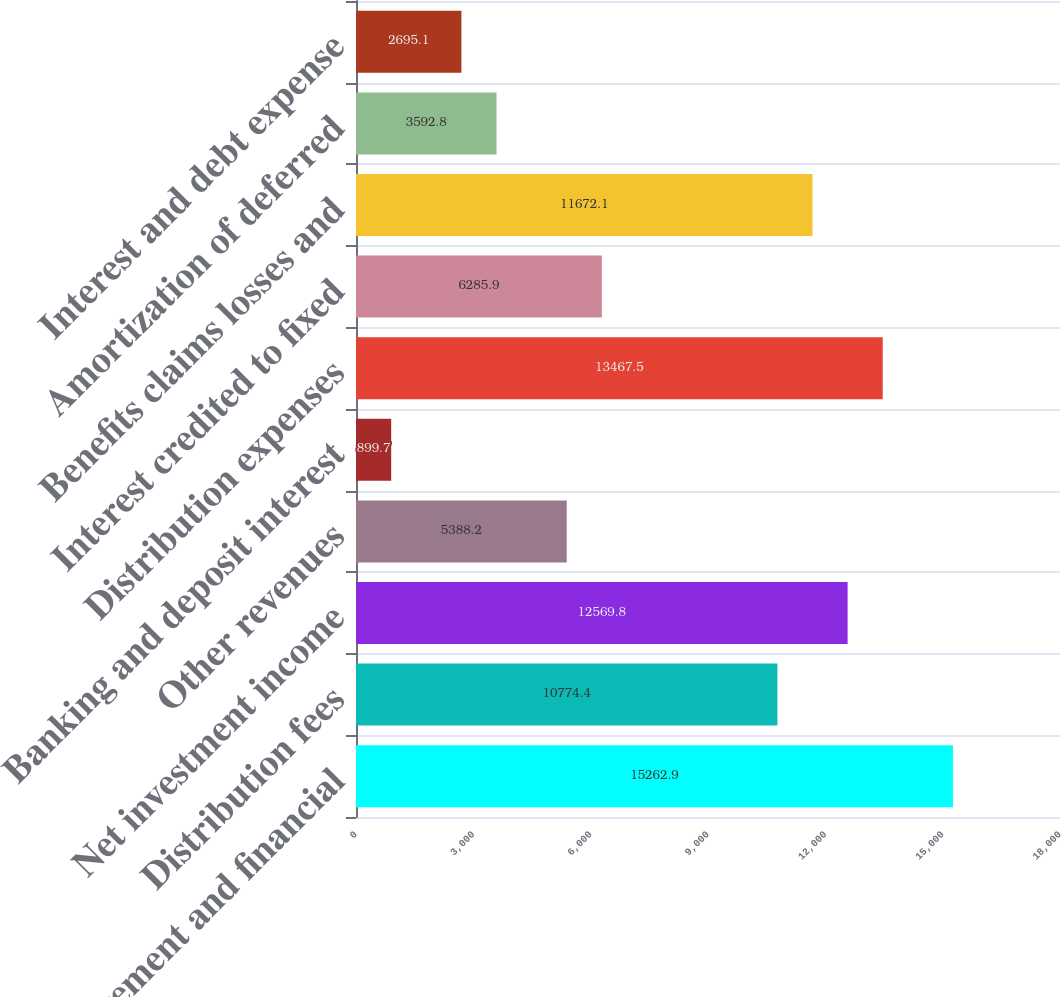Convert chart. <chart><loc_0><loc_0><loc_500><loc_500><bar_chart><fcel>Management and financial<fcel>Distribution fees<fcel>Net investment income<fcel>Other revenues<fcel>Banking and deposit interest<fcel>Distribution expenses<fcel>Interest credited to fixed<fcel>Benefits claims losses and<fcel>Amortization of deferred<fcel>Interest and debt expense<nl><fcel>15262.9<fcel>10774.4<fcel>12569.8<fcel>5388.2<fcel>899.7<fcel>13467.5<fcel>6285.9<fcel>11672.1<fcel>3592.8<fcel>2695.1<nl></chart> 